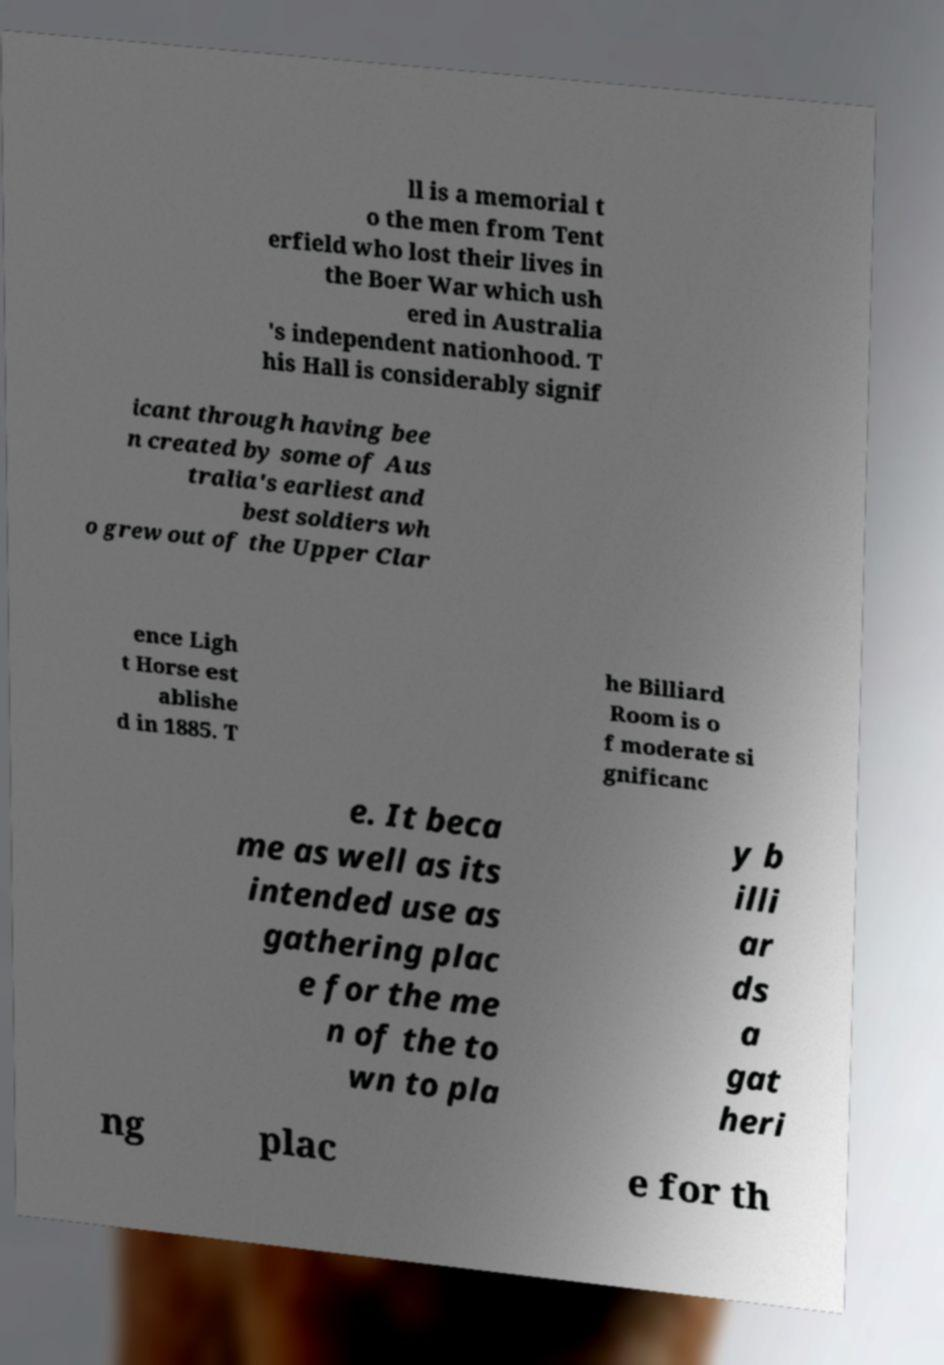For documentation purposes, I need the text within this image transcribed. Could you provide that? ll is a memorial t o the men from Tent erfield who lost their lives in the Boer War which ush ered in Australia 's independent nationhood. T his Hall is considerably signif icant through having bee n created by some of Aus tralia's earliest and best soldiers wh o grew out of the Upper Clar ence Ligh t Horse est ablishe d in 1885. T he Billiard Room is o f moderate si gnificanc e. It beca me as well as its intended use as gathering plac e for the me n of the to wn to pla y b illi ar ds a gat heri ng plac e for th 